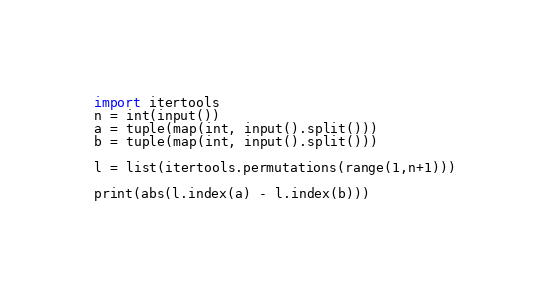<code> <loc_0><loc_0><loc_500><loc_500><_Python_>import itertools
n = int(input())
a = tuple(map(int, input().split()))
b = tuple(map(int, input().split()))

l = list(itertools.permutations(range(1,n+1)))

print(abs(l.index(a) - l.index(b)))



</code> 